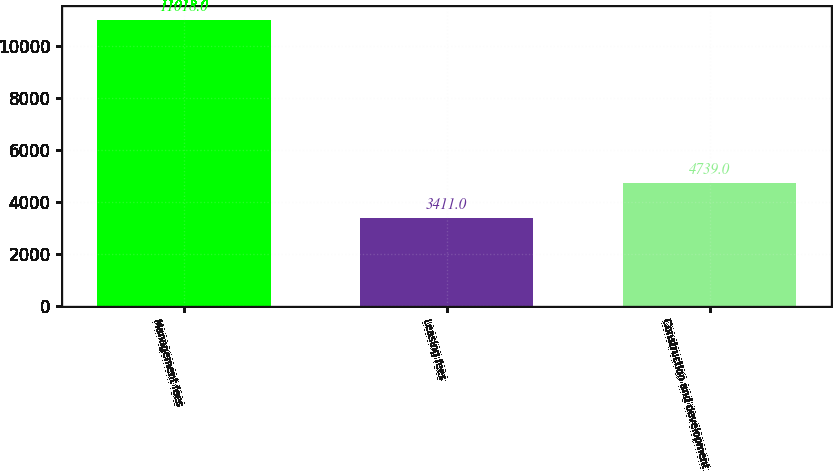<chart> <loc_0><loc_0><loc_500><loc_500><bar_chart><fcel>Management fees<fcel>Leasing fees<fcel>Construction and development<nl><fcel>11018<fcel>3411<fcel>4739<nl></chart> 